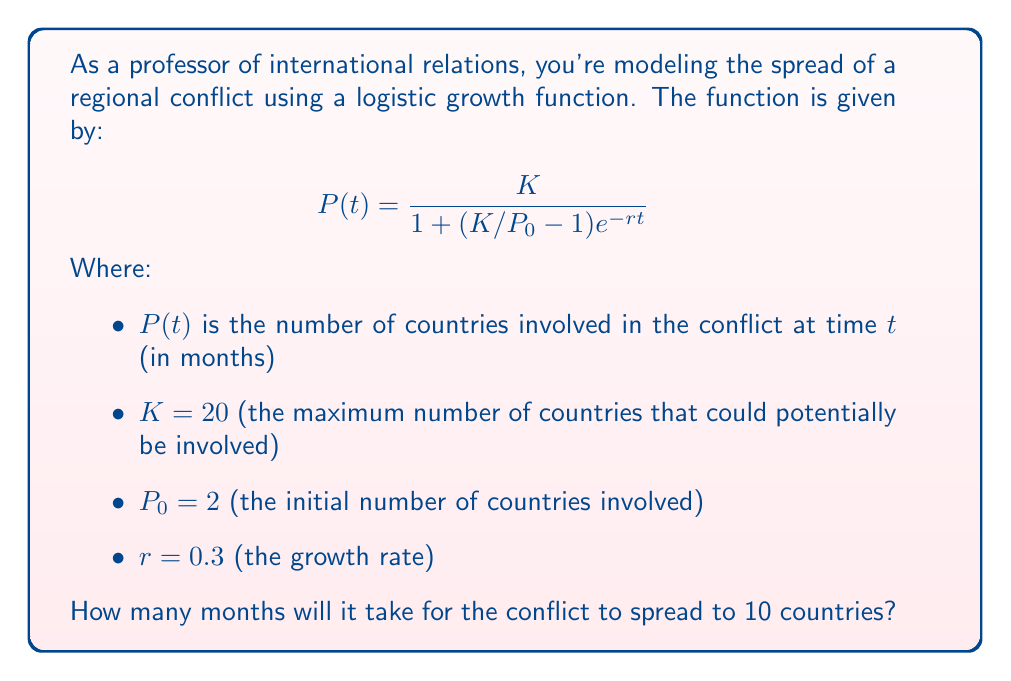What is the answer to this math problem? To solve this problem, we need to use the logistic growth function and solve for $t$ when $P(t) = 10$. Let's approach this step-by-step:

1) We start with the logistic growth function:

   $$P(t) = \frac{K}{1 + (K/P_0 - 1)e^{-rt}}$$

2) We know that $K = 20$, $P_0 = 2$, $r = 0.3$, and we want to find $t$ when $P(t) = 10$. Let's substitute these values:

   $$10 = \frac{20}{1 + (20/2 - 1)e^{-0.3t}}$$

3) Simplify the fraction in the parentheses:

   $$10 = \frac{20}{1 + 9e^{-0.3t}}$$

4) Multiply both sides by the denominator:

   $$10(1 + 9e^{-0.3t}) = 20$$

5) Distribute on the left side:

   $$10 + 90e^{-0.3t} = 20$$

6) Subtract 10 from both sides:

   $$90e^{-0.3t} = 10$$

7) Divide both sides by 90:

   $$e^{-0.3t} = \frac{1}{9}$$

8) Take the natural log of both sides:

   $$-0.3t = \ln(\frac{1}{9})$$

9) Divide both sides by -0.3:

   $$t = -\frac{\ln(\frac{1}{9})}{0.3}$$

10) Simplify:

    $$t = \frac{\ln(9)}{0.3} \approx 7.3645$$

Therefore, it will take approximately 7.36 months for the conflict to spread to 10 countries.
Answer: $7.36$ months (rounded to two decimal places) 